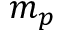<formula> <loc_0><loc_0><loc_500><loc_500>m _ { p }</formula> 